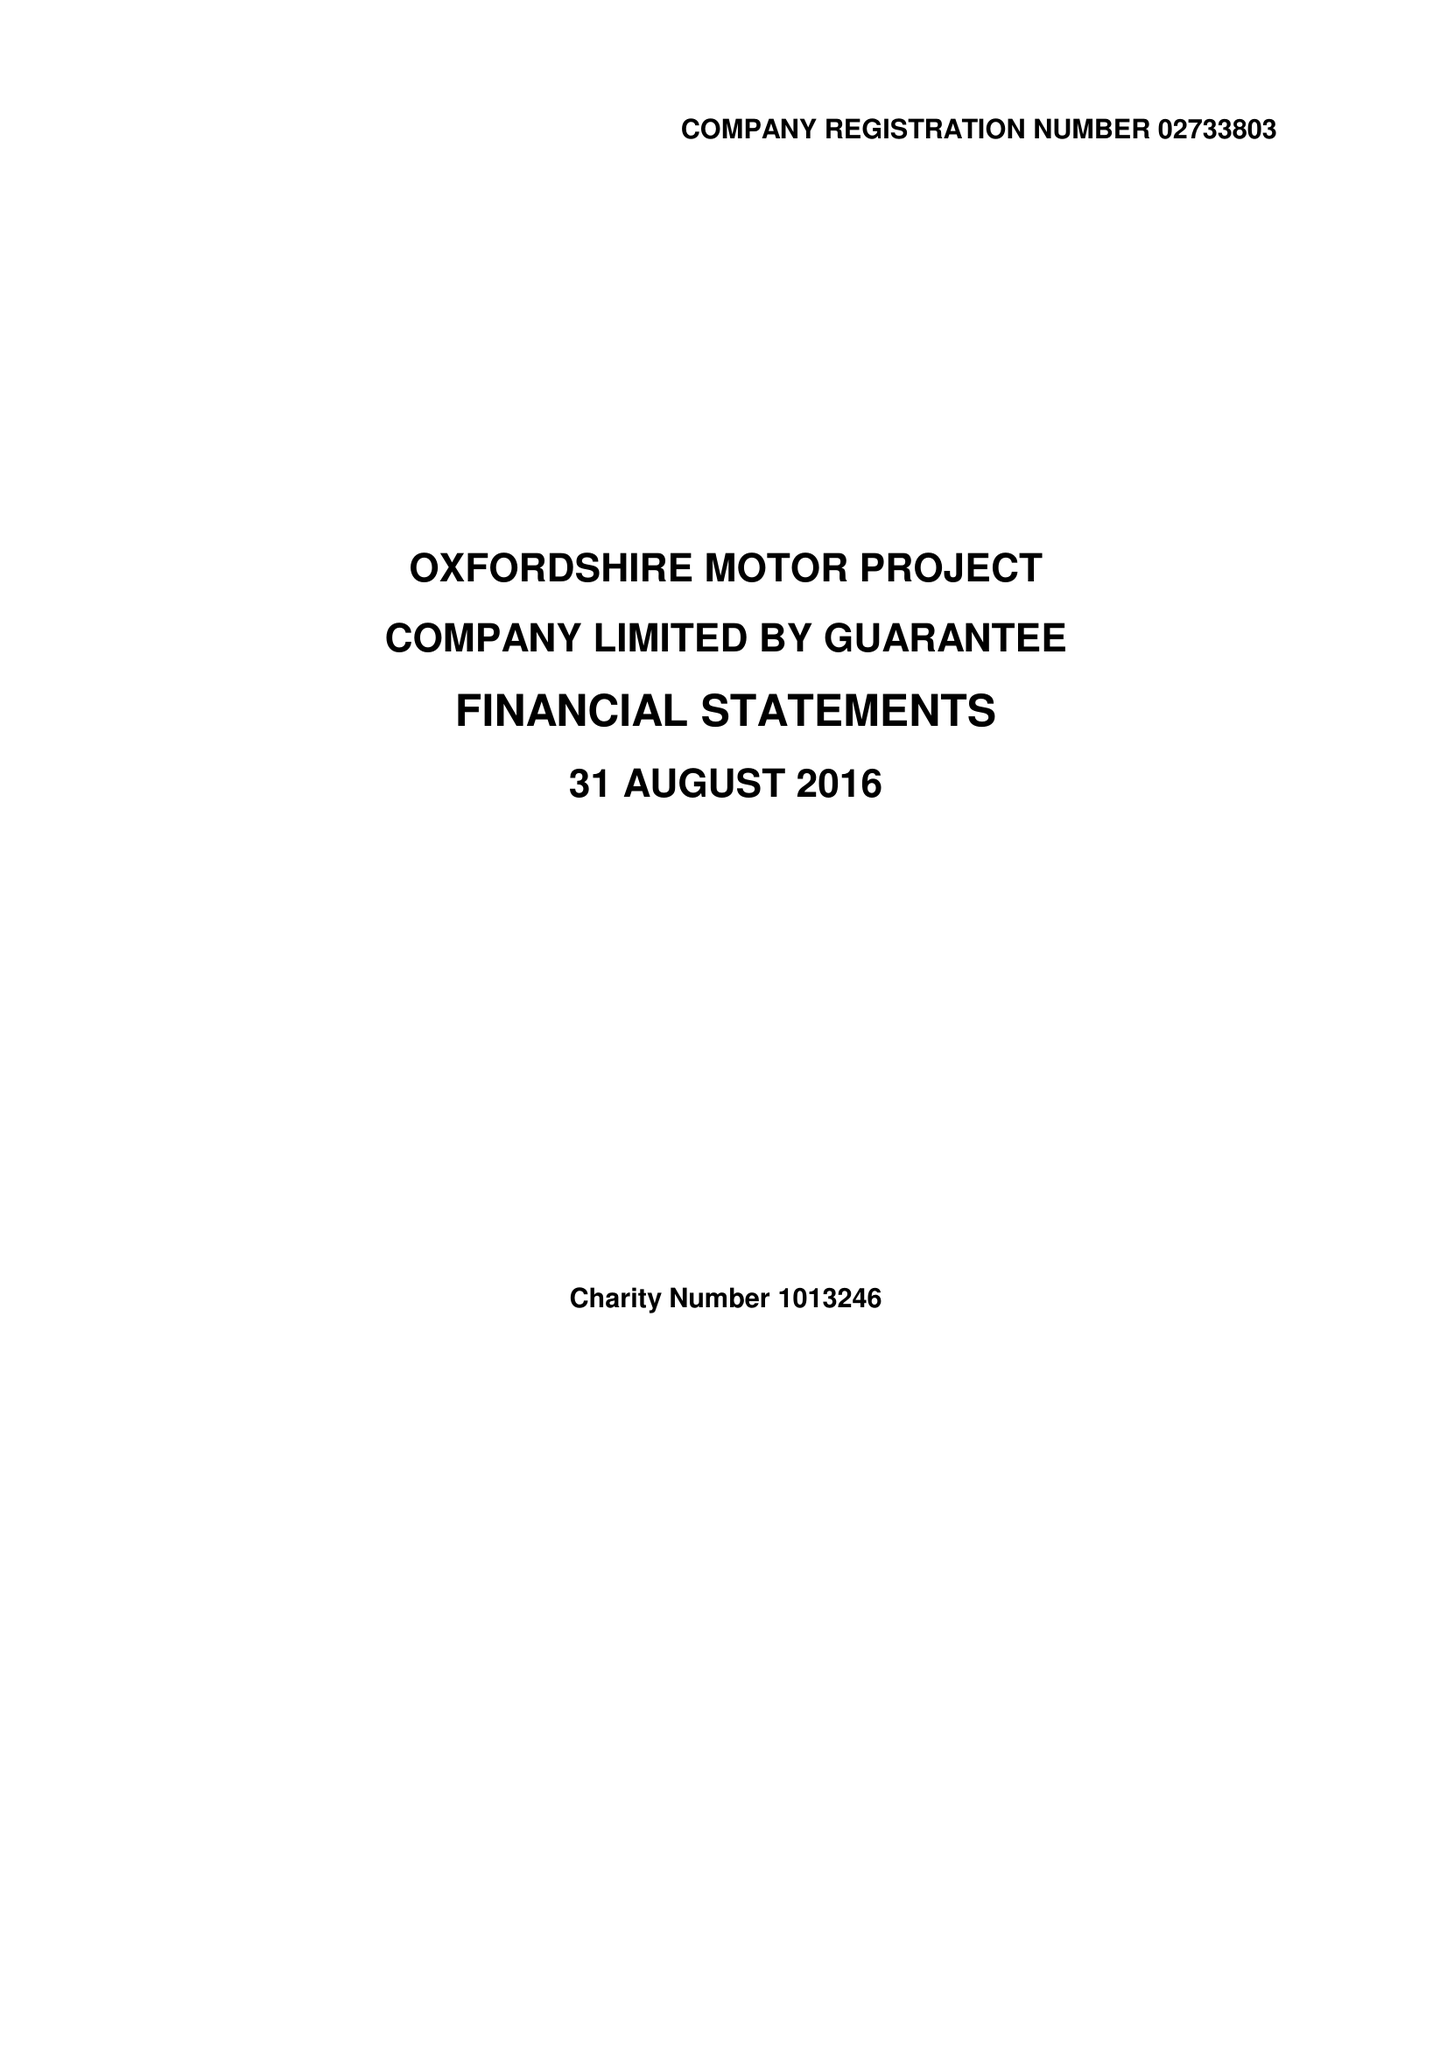What is the value for the address__post_town?
Answer the question using a single word or phrase. OXFORD 